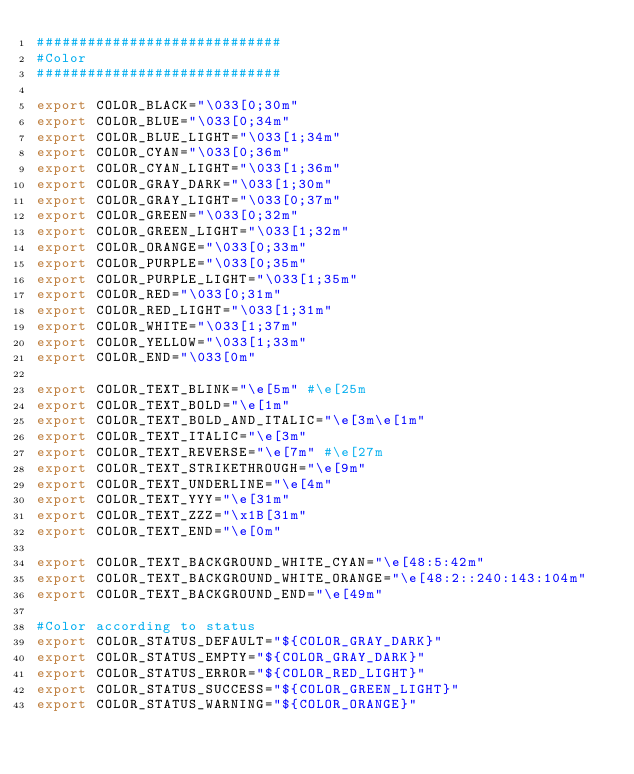<code> <loc_0><loc_0><loc_500><loc_500><_Bash_>#############################
#Color
#############################

export COLOR_BLACK="\033[0;30m"
export COLOR_BLUE="\033[0;34m"
export COLOR_BLUE_LIGHT="\033[1;34m"
export COLOR_CYAN="\033[0;36m"
export COLOR_CYAN_LIGHT="\033[1;36m"
export COLOR_GRAY_DARK="\033[1;30m"
export COLOR_GRAY_LIGHT="\033[0;37m"
export COLOR_GREEN="\033[0;32m"
export COLOR_GREEN_LIGHT="\033[1;32m"
export COLOR_ORANGE="\033[0;33m"
export COLOR_PURPLE="\033[0;35m"
export COLOR_PURPLE_LIGHT="\033[1;35m"
export COLOR_RED="\033[0;31m"
export COLOR_RED_LIGHT="\033[1;31m"
export COLOR_WHITE="\033[1;37m"
export COLOR_YELLOW="\033[1;33m"
export COLOR_END="\033[0m"

export COLOR_TEXT_BLINK="\e[5m" #\e[25m
export COLOR_TEXT_BOLD="\e[1m"
export COLOR_TEXT_BOLD_AND_ITALIC="\e[3m\e[1m"
export COLOR_TEXT_ITALIC="\e[3m"
export COLOR_TEXT_REVERSE="\e[7m" #\e[27m
export COLOR_TEXT_STRIKETHROUGH="\e[9m"
export COLOR_TEXT_UNDERLINE="\e[4m"
export COLOR_TEXT_YYY="\e[31m"
export COLOR_TEXT_ZZZ="\x1B[31m"
export COLOR_TEXT_END="\e[0m"

export COLOR_TEXT_BACKGROUND_WHITE_CYAN="\e[48:5:42m"
export COLOR_TEXT_BACKGROUND_WHITE_ORANGE="\e[48:2::240:143:104m"
export COLOR_TEXT_BACKGROUND_END="\e[49m"

#Color according to status
export COLOR_STATUS_DEFAULT="${COLOR_GRAY_DARK}"
export COLOR_STATUS_EMPTY="${COLOR_GRAY_DARK}"
export COLOR_STATUS_ERROR="${COLOR_RED_LIGHT}"
export COLOR_STATUS_SUCCESS="${COLOR_GREEN_LIGHT}"
export COLOR_STATUS_WARNING="${COLOR_ORANGE}"
</code> 